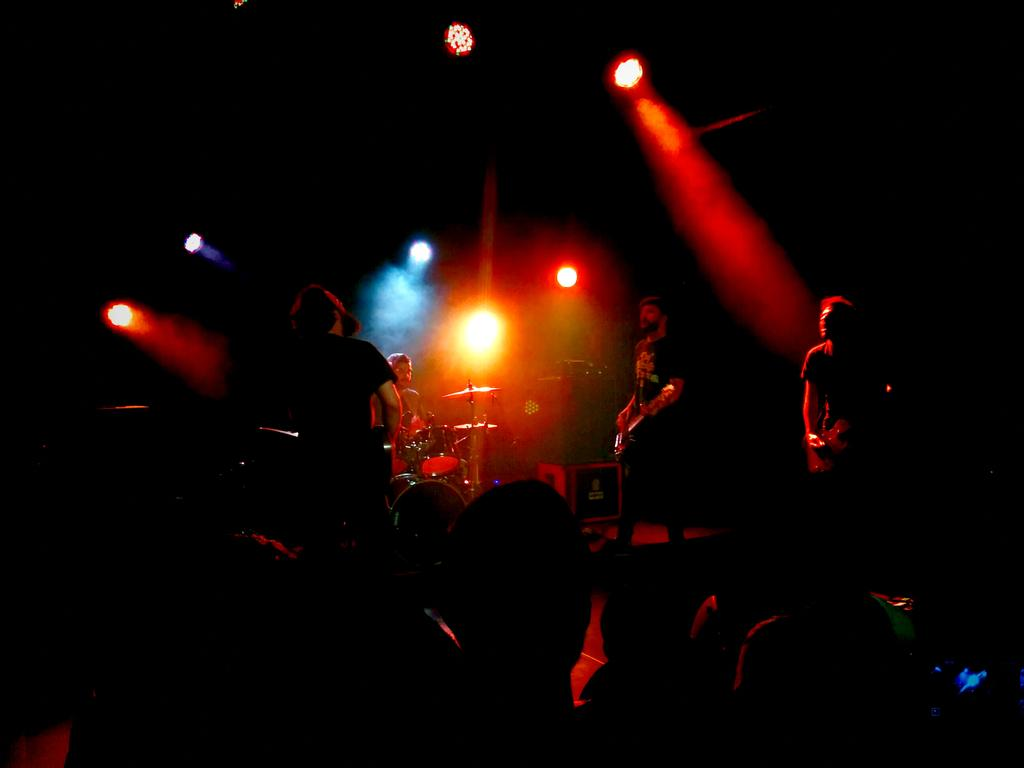What is the main subject of the image? The main subject of the image is a group of people. What objects are associated with the group of people in the image? There are drums, cymbals, speakers, and focus lights in the image. How are the cymbals positioned in the image? The cymbals are attached to cymbal stands in the image. What are the group of people doing in the image? The group of people are holding musical instruments. Can you tell me how many bubbles are floating around the cactus in the image? There is no cactus or bubble present in the image. 